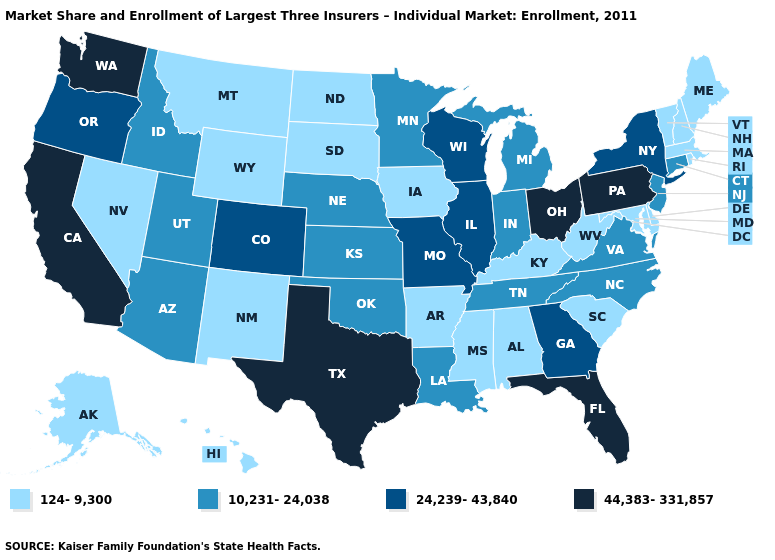Does Connecticut have the lowest value in the Northeast?
Quick response, please. No. Among the states that border North Dakota , which have the lowest value?
Concise answer only. Montana, South Dakota. Name the states that have a value in the range 44,383-331,857?
Write a very short answer. California, Florida, Ohio, Pennsylvania, Texas, Washington. What is the value of Connecticut?
Short answer required. 10,231-24,038. Which states have the lowest value in the USA?
Quick response, please. Alabama, Alaska, Arkansas, Delaware, Hawaii, Iowa, Kentucky, Maine, Maryland, Massachusetts, Mississippi, Montana, Nevada, New Hampshire, New Mexico, North Dakota, Rhode Island, South Carolina, South Dakota, Vermont, West Virginia, Wyoming. Does the map have missing data?
Short answer required. No. What is the value of Virginia?
Give a very brief answer. 10,231-24,038. Name the states that have a value in the range 10,231-24,038?
Keep it brief. Arizona, Connecticut, Idaho, Indiana, Kansas, Louisiana, Michigan, Minnesota, Nebraska, New Jersey, North Carolina, Oklahoma, Tennessee, Utah, Virginia. What is the value of Tennessee?
Write a very short answer. 10,231-24,038. What is the highest value in the Northeast ?
Quick response, please. 44,383-331,857. What is the lowest value in states that border Kentucky?
Quick response, please. 124-9,300. Does Michigan have a lower value than Idaho?
Be succinct. No. How many symbols are there in the legend?
Concise answer only. 4. What is the value of Utah?
Concise answer only. 10,231-24,038. Name the states that have a value in the range 124-9,300?
Short answer required. Alabama, Alaska, Arkansas, Delaware, Hawaii, Iowa, Kentucky, Maine, Maryland, Massachusetts, Mississippi, Montana, Nevada, New Hampshire, New Mexico, North Dakota, Rhode Island, South Carolina, South Dakota, Vermont, West Virginia, Wyoming. 